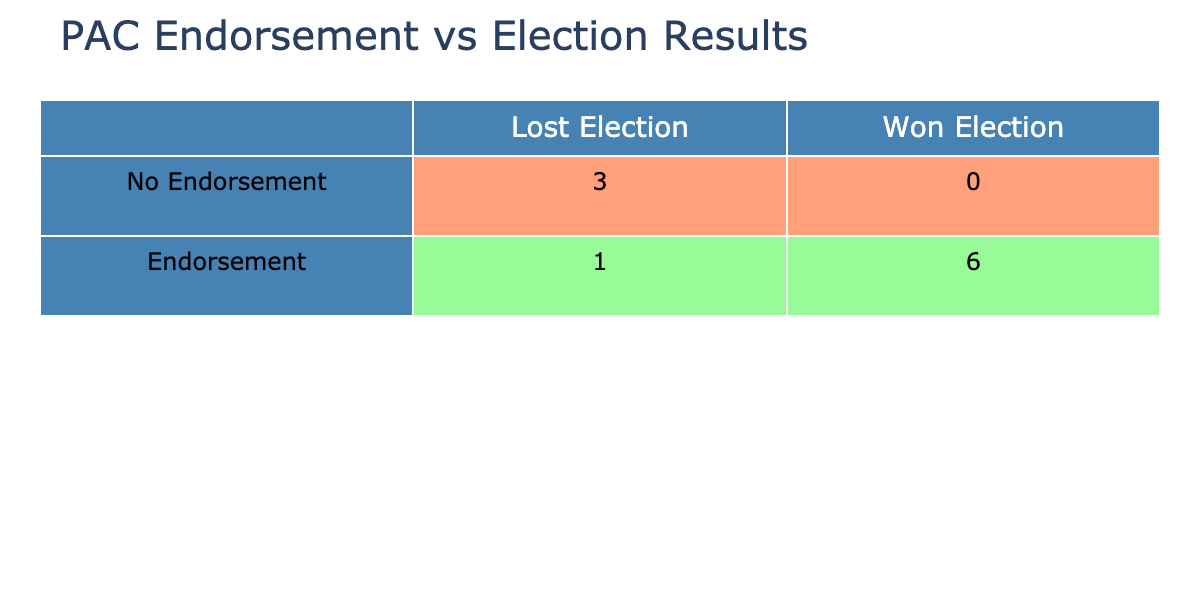What is the number of candidates that received no endorsement and won the election? In the table, we look for candidates with "No" under the endorsement column and "Yes" under the won election column. There are no candidates who fall into this category.
Answer: 0 How many candidates received an endorsement and lost the election? We check the endorsement column for "Yes" and the won election column for "No". The only candidate who meets this criterion is Sarah Lee, which means there is one candidate.
Answer: 1 What is the total funding received by candidates who received endorsements? We filter the table to only include candidates with "Yes" under the endorsement column (Mark Johnson, Emily Carter, Tom Reed, Sarah Lee, John Smith, Paul Davis, Daniel Green) and sum their funding received: 500000 + 300000 + 200000 + 150000 + 100000 + 400000 + 220000 = 1870000.
Answer: 1870000 Did any candidates with no endorsement win the election? We check the candidates with "No" under the endorsement column and see if any of them have "Yes" under the won election column. According to the table, Freedom Partners (Kevin Brown) and Club for Growth (Jessica Miller) both received no endorsements and lost, indicating none won.
Answer: No What percentage of endorsed candidates won their elections? First, we count the endorsed candidates: 7 (Mark Johnson, Emily Carter, Tom Reed, Sarah Lee, John Smith, Paul Davis, Daniel Green). Among them, the winners are Mark Johnson, Emily Carter, Tom Reed, John Smith, Paul Davis, and Daniel Green, totaling 6. Therefore, to calculate the percentage: (6/7) * 100 = 85.71%.
Answer: 85.71% How many candidates in total won the election? We look through the won election column and count the number of "Yes" entries. The candidates who won are Mark Johnson, Emily Carter, Tom Reed, John Smith, Paul Davis, and Daniel Green, totaling to 6 candidates.
Answer: 6 What is the ratio of candidates that received endorsements to those that did not? In the table, there are 7 candidates with endorsements (Yes) and 3 candidates without (No). Therefore, we can express the ratio as 7:3.
Answer: 7:3 Is there a candidate who received more funding than the average funding of candidates who won the election? We first calculate the average funding for the winning candidates (Mark Johnson, Emily Carter, Tom Reed, John Smith, Paul Davis, Daniel Green) which totals 1870000 and divides by 6 (the number of winning candidates) yielding an average of 311666.67. We note that Freedom Partners (Kevin Brown) received 250000 funding, which is less than this average, meaning no candidates exceed it.
Answer: No 